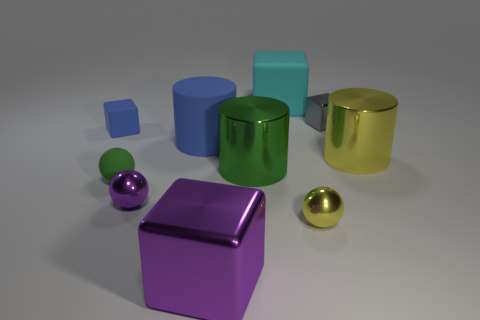Is there anything else that has the same size as the green matte thing?
Offer a terse response. Yes. Is the number of cyan matte blocks on the left side of the large cyan thing less than the number of large blue rubber cylinders that are right of the large green cylinder?
Ensure brevity in your answer.  No. What is the color of the big matte cube?
Offer a very short reply. Cyan. Are there any large rubber blocks of the same color as the matte sphere?
Offer a very short reply. No. What shape is the tiny blue thing on the left side of the big block that is on the left side of the big block that is behind the gray object?
Offer a terse response. Cube. There is a yellow object behind the green sphere; what is it made of?
Provide a succinct answer. Metal. There is a shiny object to the right of the small cube behind the tiny block that is to the left of the big purple thing; what size is it?
Make the answer very short. Large. Does the yellow metal ball have the same size as the metallic cube left of the big matte block?
Your response must be concise. No. What is the color of the tiny rubber thing that is in front of the large yellow object?
Make the answer very short. Green. There is a small thing that is the same color as the big rubber cylinder; what shape is it?
Give a very brief answer. Cube. 